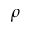<formula> <loc_0><loc_0><loc_500><loc_500>\rho</formula> 